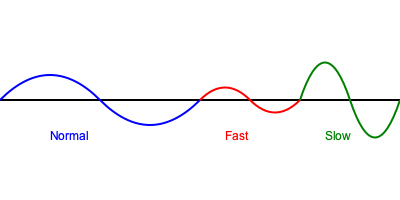Based on the audio wave patterns visualized in the graph, which speech rate in a screen reader would likely correspond to the green waveform? To determine the speech rate corresponding to the green waveform, let's analyze the characteristics of each waveform:

1. Blue waveform:
   - Has a moderate frequency and amplitude
   - Represents a normal or standard speech rate

2. Red waveform:
   - Has a higher frequency (more waves in the same space)
   - Represents a faster speech rate

3. Green waveform:
   - Has a lower frequency (fewer waves in the same space)
   - Has a larger amplitude (taller waves)
   - Represents a slower speech rate

In audio processing, lower frequency waves typically correspond to slower speech rates, while higher frequency waves correspond to faster speech rates. The green waveform has the lowest frequency among the three, indicating it represents the slowest speech rate.

Additionally, the larger amplitude of the green waveform suggests that each word or syllable is more drawn out, which is characteristic of slower speech.

Therefore, the green waveform most likely corresponds to the slow speech rate setting in a screen reader.
Answer: Slow speech rate 